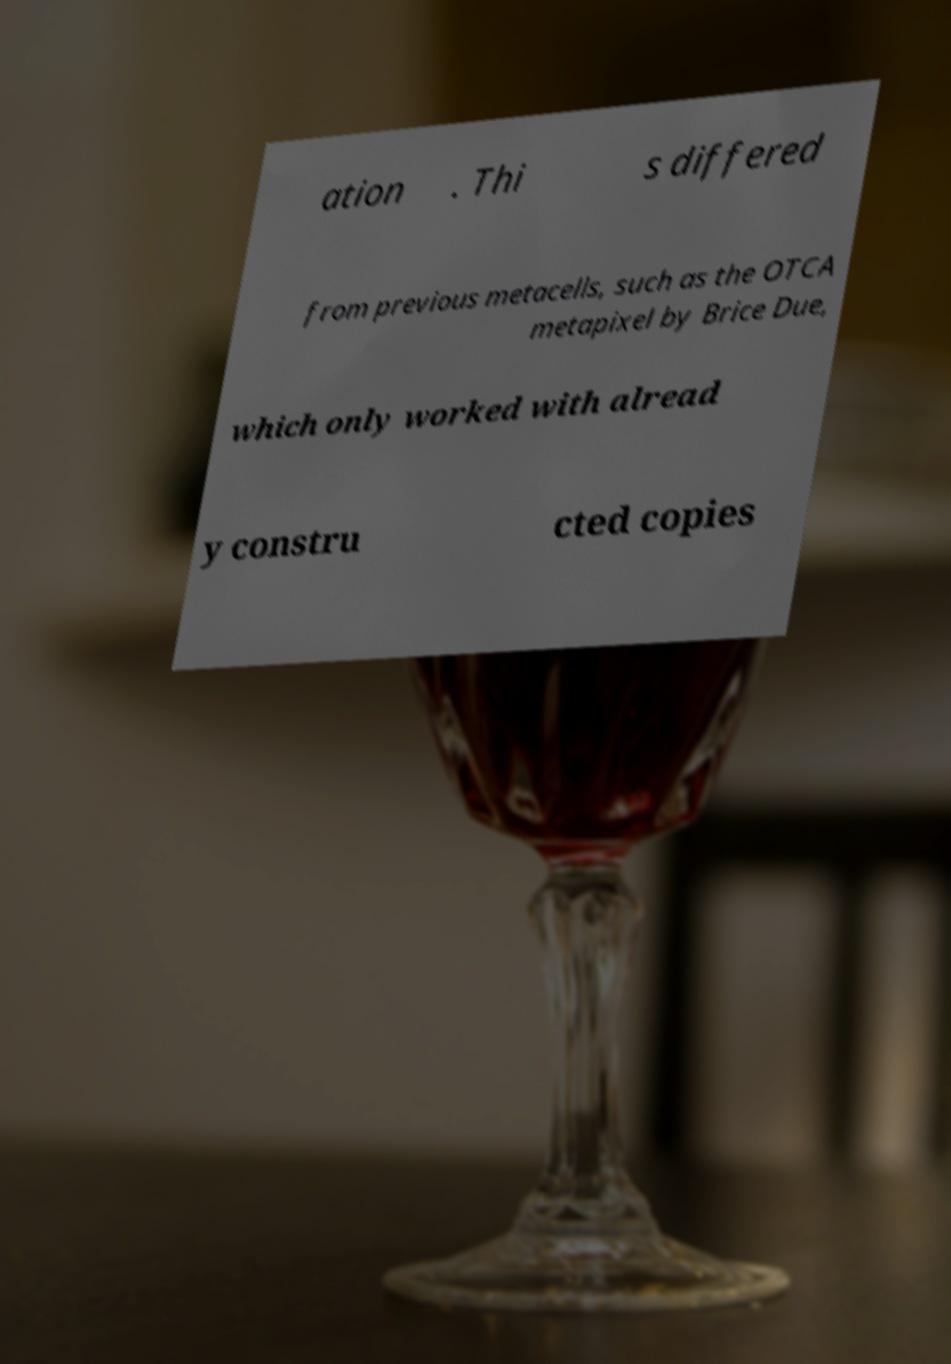I need the written content from this picture converted into text. Can you do that? ation . Thi s differed from previous metacells, such as the OTCA metapixel by Brice Due, which only worked with alread y constru cted copies 